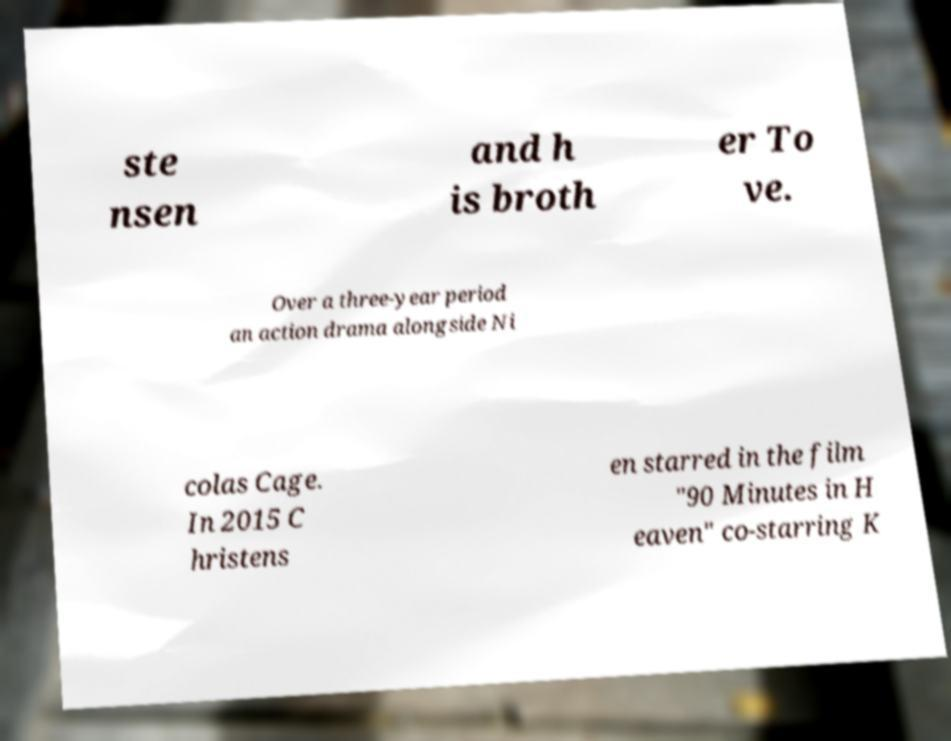Please identify and transcribe the text found in this image. ste nsen and h is broth er To ve. Over a three-year period an action drama alongside Ni colas Cage. In 2015 C hristens en starred in the film "90 Minutes in H eaven" co-starring K 